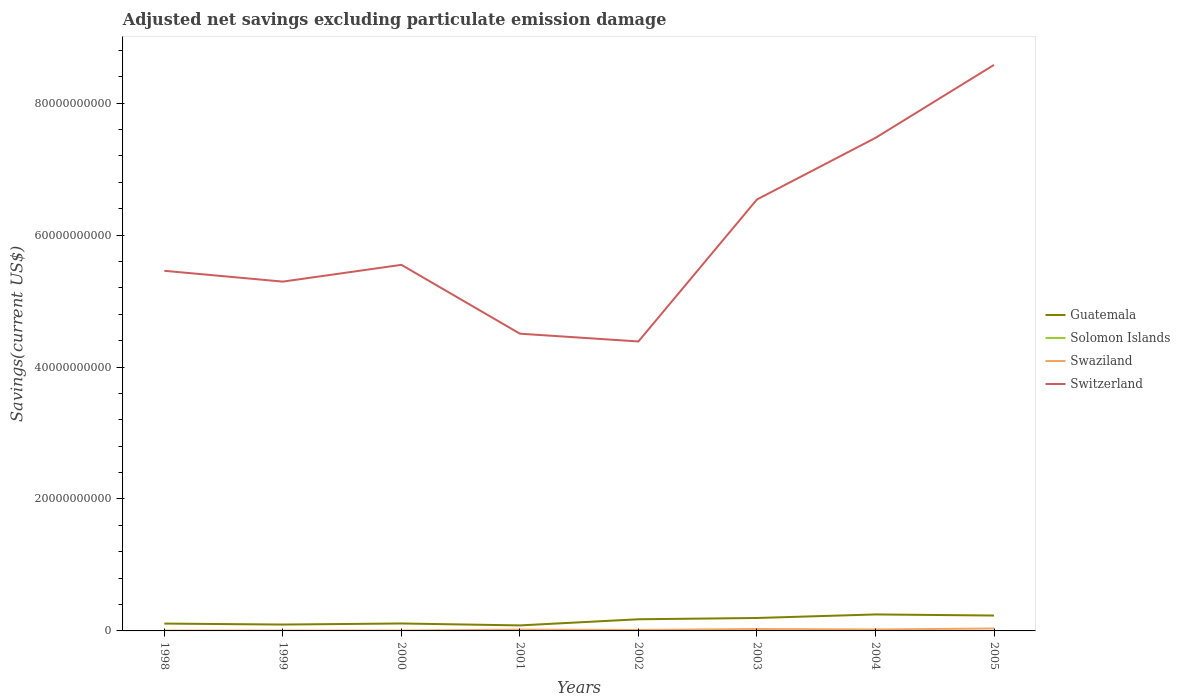How many different coloured lines are there?
Make the answer very short. 4. Across all years, what is the maximum adjusted net savings in Guatemala?
Your answer should be compact. 8.35e+08. What is the total adjusted net savings in Switzerland in the graph?
Your response must be concise. -4.07e+1. What is the difference between the highest and the second highest adjusted net savings in Guatemala?
Your answer should be compact. 1.66e+09. How many lines are there?
Ensure brevity in your answer.  4. How many years are there in the graph?
Your answer should be compact. 8. What is the difference between two consecutive major ticks on the Y-axis?
Provide a succinct answer. 2.00e+1. Are the values on the major ticks of Y-axis written in scientific E-notation?
Provide a short and direct response. No. Does the graph contain grids?
Your response must be concise. No. What is the title of the graph?
Ensure brevity in your answer.  Adjusted net savings excluding particulate emission damage. Does "Solomon Islands" appear as one of the legend labels in the graph?
Make the answer very short. Yes. What is the label or title of the X-axis?
Your answer should be very brief. Years. What is the label or title of the Y-axis?
Ensure brevity in your answer.  Savings(current US$). What is the Savings(current US$) in Guatemala in 1998?
Your answer should be very brief. 1.11e+09. What is the Savings(current US$) of Solomon Islands in 1998?
Ensure brevity in your answer.  0. What is the Savings(current US$) in Swaziland in 1998?
Your answer should be compact. 5.31e+07. What is the Savings(current US$) of Switzerland in 1998?
Make the answer very short. 5.46e+1. What is the Savings(current US$) in Guatemala in 1999?
Provide a short and direct response. 9.67e+08. What is the Savings(current US$) of Swaziland in 1999?
Make the answer very short. 5.98e+07. What is the Savings(current US$) of Switzerland in 1999?
Keep it short and to the point. 5.29e+1. What is the Savings(current US$) in Guatemala in 2000?
Offer a very short reply. 1.13e+09. What is the Savings(current US$) in Swaziland in 2000?
Provide a short and direct response. 5.99e+07. What is the Savings(current US$) of Switzerland in 2000?
Provide a succinct answer. 5.55e+1. What is the Savings(current US$) of Guatemala in 2001?
Give a very brief answer. 8.35e+08. What is the Savings(current US$) in Swaziland in 2001?
Give a very brief answer. 1.97e+08. What is the Savings(current US$) in Switzerland in 2001?
Offer a terse response. 4.51e+1. What is the Savings(current US$) of Guatemala in 2002?
Offer a very short reply. 1.77e+09. What is the Savings(current US$) of Swaziland in 2002?
Ensure brevity in your answer.  1.44e+08. What is the Savings(current US$) of Switzerland in 2002?
Ensure brevity in your answer.  4.39e+1. What is the Savings(current US$) of Guatemala in 2003?
Your response must be concise. 1.96e+09. What is the Savings(current US$) of Solomon Islands in 2003?
Offer a very short reply. 9.45e+05. What is the Savings(current US$) in Swaziland in 2003?
Provide a succinct answer. 2.91e+08. What is the Savings(current US$) in Switzerland in 2003?
Keep it short and to the point. 6.54e+1. What is the Savings(current US$) of Guatemala in 2004?
Your response must be concise. 2.50e+09. What is the Savings(current US$) of Solomon Islands in 2004?
Keep it short and to the point. 0. What is the Savings(current US$) of Swaziland in 2004?
Provide a short and direct response. 2.19e+08. What is the Savings(current US$) in Switzerland in 2004?
Make the answer very short. 7.47e+1. What is the Savings(current US$) in Guatemala in 2005?
Offer a very short reply. 2.33e+09. What is the Savings(current US$) of Swaziland in 2005?
Your answer should be very brief. 3.69e+08. What is the Savings(current US$) in Switzerland in 2005?
Provide a succinct answer. 8.58e+1. Across all years, what is the maximum Savings(current US$) in Guatemala?
Your response must be concise. 2.50e+09. Across all years, what is the maximum Savings(current US$) in Solomon Islands?
Ensure brevity in your answer.  9.45e+05. Across all years, what is the maximum Savings(current US$) in Swaziland?
Provide a short and direct response. 3.69e+08. Across all years, what is the maximum Savings(current US$) of Switzerland?
Your answer should be compact. 8.58e+1. Across all years, what is the minimum Savings(current US$) of Guatemala?
Your response must be concise. 8.35e+08. Across all years, what is the minimum Savings(current US$) of Solomon Islands?
Ensure brevity in your answer.  0. Across all years, what is the minimum Savings(current US$) in Swaziland?
Offer a very short reply. 5.31e+07. Across all years, what is the minimum Savings(current US$) in Switzerland?
Provide a short and direct response. 4.39e+1. What is the total Savings(current US$) in Guatemala in the graph?
Make the answer very short. 1.26e+1. What is the total Savings(current US$) in Solomon Islands in the graph?
Provide a short and direct response. 9.45e+05. What is the total Savings(current US$) in Swaziland in the graph?
Your answer should be very brief. 1.39e+09. What is the total Savings(current US$) in Switzerland in the graph?
Give a very brief answer. 4.78e+11. What is the difference between the Savings(current US$) in Guatemala in 1998 and that in 1999?
Offer a terse response. 1.46e+08. What is the difference between the Savings(current US$) of Swaziland in 1998 and that in 1999?
Ensure brevity in your answer.  -6.63e+06. What is the difference between the Savings(current US$) in Switzerland in 1998 and that in 1999?
Ensure brevity in your answer.  1.64e+09. What is the difference between the Savings(current US$) of Guatemala in 1998 and that in 2000?
Ensure brevity in your answer.  -1.32e+07. What is the difference between the Savings(current US$) of Swaziland in 1998 and that in 2000?
Keep it short and to the point. -6.71e+06. What is the difference between the Savings(current US$) in Switzerland in 1998 and that in 2000?
Your answer should be very brief. -9.01e+08. What is the difference between the Savings(current US$) in Guatemala in 1998 and that in 2001?
Offer a very short reply. 2.78e+08. What is the difference between the Savings(current US$) in Swaziland in 1998 and that in 2001?
Your answer should be compact. -1.44e+08. What is the difference between the Savings(current US$) in Switzerland in 1998 and that in 2001?
Give a very brief answer. 9.53e+09. What is the difference between the Savings(current US$) in Guatemala in 1998 and that in 2002?
Give a very brief answer. -6.53e+08. What is the difference between the Savings(current US$) in Swaziland in 1998 and that in 2002?
Ensure brevity in your answer.  -9.08e+07. What is the difference between the Savings(current US$) of Switzerland in 1998 and that in 2002?
Provide a succinct answer. 1.07e+1. What is the difference between the Savings(current US$) in Guatemala in 1998 and that in 2003?
Provide a succinct answer. -8.48e+08. What is the difference between the Savings(current US$) of Swaziland in 1998 and that in 2003?
Your answer should be compact. -2.38e+08. What is the difference between the Savings(current US$) of Switzerland in 1998 and that in 2003?
Offer a very short reply. -1.08e+1. What is the difference between the Savings(current US$) of Guatemala in 1998 and that in 2004?
Give a very brief answer. -1.38e+09. What is the difference between the Savings(current US$) of Swaziland in 1998 and that in 2004?
Your response must be concise. -1.66e+08. What is the difference between the Savings(current US$) of Switzerland in 1998 and that in 2004?
Make the answer very short. -2.01e+1. What is the difference between the Savings(current US$) in Guatemala in 1998 and that in 2005?
Give a very brief answer. -1.22e+09. What is the difference between the Savings(current US$) in Swaziland in 1998 and that in 2005?
Offer a very short reply. -3.16e+08. What is the difference between the Savings(current US$) of Switzerland in 1998 and that in 2005?
Your response must be concise. -3.12e+1. What is the difference between the Savings(current US$) in Guatemala in 1999 and that in 2000?
Give a very brief answer. -1.59e+08. What is the difference between the Savings(current US$) in Swaziland in 1999 and that in 2000?
Make the answer very short. -7.67e+04. What is the difference between the Savings(current US$) of Switzerland in 1999 and that in 2000?
Make the answer very short. -2.54e+09. What is the difference between the Savings(current US$) in Guatemala in 1999 and that in 2001?
Keep it short and to the point. 1.32e+08. What is the difference between the Savings(current US$) in Swaziland in 1999 and that in 2001?
Provide a succinct answer. -1.37e+08. What is the difference between the Savings(current US$) in Switzerland in 1999 and that in 2001?
Offer a very short reply. 7.89e+09. What is the difference between the Savings(current US$) in Guatemala in 1999 and that in 2002?
Offer a very short reply. -7.99e+08. What is the difference between the Savings(current US$) in Swaziland in 1999 and that in 2002?
Keep it short and to the point. -8.41e+07. What is the difference between the Savings(current US$) in Switzerland in 1999 and that in 2002?
Your response must be concise. 9.07e+09. What is the difference between the Savings(current US$) in Guatemala in 1999 and that in 2003?
Make the answer very short. -9.94e+08. What is the difference between the Savings(current US$) of Swaziland in 1999 and that in 2003?
Your answer should be very brief. -2.32e+08. What is the difference between the Savings(current US$) of Switzerland in 1999 and that in 2003?
Give a very brief answer. -1.25e+1. What is the difference between the Savings(current US$) in Guatemala in 1999 and that in 2004?
Your answer should be compact. -1.53e+09. What is the difference between the Savings(current US$) in Swaziland in 1999 and that in 2004?
Give a very brief answer. -1.60e+08. What is the difference between the Savings(current US$) of Switzerland in 1999 and that in 2004?
Keep it short and to the point. -2.18e+1. What is the difference between the Savings(current US$) in Guatemala in 1999 and that in 2005?
Keep it short and to the point. -1.37e+09. What is the difference between the Savings(current US$) of Swaziland in 1999 and that in 2005?
Provide a succinct answer. -3.09e+08. What is the difference between the Savings(current US$) in Switzerland in 1999 and that in 2005?
Keep it short and to the point. -3.28e+1. What is the difference between the Savings(current US$) in Guatemala in 2000 and that in 2001?
Your answer should be very brief. 2.91e+08. What is the difference between the Savings(current US$) in Swaziland in 2000 and that in 2001?
Offer a terse response. -1.37e+08. What is the difference between the Savings(current US$) in Switzerland in 2000 and that in 2001?
Make the answer very short. 1.04e+1. What is the difference between the Savings(current US$) of Guatemala in 2000 and that in 2002?
Offer a very short reply. -6.40e+08. What is the difference between the Savings(current US$) in Swaziland in 2000 and that in 2002?
Give a very brief answer. -8.41e+07. What is the difference between the Savings(current US$) of Switzerland in 2000 and that in 2002?
Offer a terse response. 1.16e+1. What is the difference between the Savings(current US$) in Guatemala in 2000 and that in 2003?
Offer a very short reply. -8.35e+08. What is the difference between the Savings(current US$) in Swaziland in 2000 and that in 2003?
Offer a terse response. -2.32e+08. What is the difference between the Savings(current US$) of Switzerland in 2000 and that in 2003?
Provide a short and direct response. -9.91e+09. What is the difference between the Savings(current US$) of Guatemala in 2000 and that in 2004?
Your answer should be very brief. -1.37e+09. What is the difference between the Savings(current US$) of Swaziland in 2000 and that in 2004?
Provide a succinct answer. -1.60e+08. What is the difference between the Savings(current US$) of Switzerland in 2000 and that in 2004?
Your answer should be very brief. -1.92e+1. What is the difference between the Savings(current US$) in Guatemala in 2000 and that in 2005?
Make the answer very short. -1.21e+09. What is the difference between the Savings(current US$) of Swaziland in 2000 and that in 2005?
Keep it short and to the point. -3.09e+08. What is the difference between the Savings(current US$) in Switzerland in 2000 and that in 2005?
Offer a terse response. -3.03e+1. What is the difference between the Savings(current US$) of Guatemala in 2001 and that in 2002?
Give a very brief answer. -9.30e+08. What is the difference between the Savings(current US$) in Swaziland in 2001 and that in 2002?
Ensure brevity in your answer.  5.32e+07. What is the difference between the Savings(current US$) in Switzerland in 2001 and that in 2002?
Your response must be concise. 1.18e+09. What is the difference between the Savings(current US$) of Guatemala in 2001 and that in 2003?
Ensure brevity in your answer.  -1.13e+09. What is the difference between the Savings(current US$) of Swaziland in 2001 and that in 2003?
Provide a short and direct response. -9.43e+07. What is the difference between the Savings(current US$) in Switzerland in 2001 and that in 2003?
Offer a terse response. -2.03e+1. What is the difference between the Savings(current US$) in Guatemala in 2001 and that in 2004?
Offer a very short reply. -1.66e+09. What is the difference between the Savings(current US$) of Swaziland in 2001 and that in 2004?
Your response must be concise. -2.23e+07. What is the difference between the Savings(current US$) of Switzerland in 2001 and that in 2004?
Offer a very short reply. -2.97e+1. What is the difference between the Savings(current US$) in Guatemala in 2001 and that in 2005?
Keep it short and to the point. -1.50e+09. What is the difference between the Savings(current US$) in Swaziland in 2001 and that in 2005?
Provide a succinct answer. -1.72e+08. What is the difference between the Savings(current US$) of Switzerland in 2001 and that in 2005?
Offer a very short reply. -4.07e+1. What is the difference between the Savings(current US$) of Guatemala in 2002 and that in 2003?
Ensure brevity in your answer.  -1.95e+08. What is the difference between the Savings(current US$) of Swaziland in 2002 and that in 2003?
Provide a succinct answer. -1.48e+08. What is the difference between the Savings(current US$) of Switzerland in 2002 and that in 2003?
Keep it short and to the point. -2.15e+1. What is the difference between the Savings(current US$) in Guatemala in 2002 and that in 2004?
Provide a succinct answer. -7.32e+08. What is the difference between the Savings(current US$) of Swaziland in 2002 and that in 2004?
Ensure brevity in your answer.  -7.55e+07. What is the difference between the Savings(current US$) of Switzerland in 2002 and that in 2004?
Provide a short and direct response. -3.09e+1. What is the difference between the Savings(current US$) of Guatemala in 2002 and that in 2005?
Offer a terse response. -5.67e+08. What is the difference between the Savings(current US$) in Swaziland in 2002 and that in 2005?
Provide a succinct answer. -2.25e+08. What is the difference between the Savings(current US$) in Switzerland in 2002 and that in 2005?
Give a very brief answer. -4.19e+1. What is the difference between the Savings(current US$) in Guatemala in 2003 and that in 2004?
Offer a very short reply. -5.36e+08. What is the difference between the Savings(current US$) in Swaziland in 2003 and that in 2004?
Your answer should be very brief. 7.20e+07. What is the difference between the Savings(current US$) in Switzerland in 2003 and that in 2004?
Offer a terse response. -9.33e+09. What is the difference between the Savings(current US$) of Guatemala in 2003 and that in 2005?
Your answer should be very brief. -3.71e+08. What is the difference between the Savings(current US$) in Swaziland in 2003 and that in 2005?
Keep it short and to the point. -7.72e+07. What is the difference between the Savings(current US$) in Switzerland in 2003 and that in 2005?
Your answer should be compact. -2.04e+1. What is the difference between the Savings(current US$) of Guatemala in 2004 and that in 2005?
Keep it short and to the point. 1.65e+08. What is the difference between the Savings(current US$) of Swaziland in 2004 and that in 2005?
Make the answer very short. -1.49e+08. What is the difference between the Savings(current US$) of Switzerland in 2004 and that in 2005?
Ensure brevity in your answer.  -1.11e+1. What is the difference between the Savings(current US$) in Guatemala in 1998 and the Savings(current US$) in Swaziland in 1999?
Ensure brevity in your answer.  1.05e+09. What is the difference between the Savings(current US$) in Guatemala in 1998 and the Savings(current US$) in Switzerland in 1999?
Make the answer very short. -5.18e+1. What is the difference between the Savings(current US$) in Swaziland in 1998 and the Savings(current US$) in Switzerland in 1999?
Give a very brief answer. -5.29e+1. What is the difference between the Savings(current US$) of Guatemala in 1998 and the Savings(current US$) of Swaziland in 2000?
Your response must be concise. 1.05e+09. What is the difference between the Savings(current US$) in Guatemala in 1998 and the Savings(current US$) in Switzerland in 2000?
Keep it short and to the point. -5.44e+1. What is the difference between the Savings(current US$) of Swaziland in 1998 and the Savings(current US$) of Switzerland in 2000?
Your answer should be very brief. -5.54e+1. What is the difference between the Savings(current US$) of Guatemala in 1998 and the Savings(current US$) of Swaziland in 2001?
Make the answer very short. 9.16e+08. What is the difference between the Savings(current US$) of Guatemala in 1998 and the Savings(current US$) of Switzerland in 2001?
Your answer should be compact. -4.39e+1. What is the difference between the Savings(current US$) in Swaziland in 1998 and the Savings(current US$) in Switzerland in 2001?
Provide a short and direct response. -4.50e+1. What is the difference between the Savings(current US$) in Guatemala in 1998 and the Savings(current US$) in Swaziland in 2002?
Keep it short and to the point. 9.69e+08. What is the difference between the Savings(current US$) of Guatemala in 1998 and the Savings(current US$) of Switzerland in 2002?
Your answer should be very brief. -4.28e+1. What is the difference between the Savings(current US$) of Swaziland in 1998 and the Savings(current US$) of Switzerland in 2002?
Your response must be concise. -4.38e+1. What is the difference between the Savings(current US$) of Guatemala in 1998 and the Savings(current US$) of Solomon Islands in 2003?
Offer a very short reply. 1.11e+09. What is the difference between the Savings(current US$) of Guatemala in 1998 and the Savings(current US$) of Swaziland in 2003?
Give a very brief answer. 8.22e+08. What is the difference between the Savings(current US$) of Guatemala in 1998 and the Savings(current US$) of Switzerland in 2003?
Provide a succinct answer. -6.43e+1. What is the difference between the Savings(current US$) of Swaziland in 1998 and the Savings(current US$) of Switzerland in 2003?
Make the answer very short. -6.53e+1. What is the difference between the Savings(current US$) in Guatemala in 1998 and the Savings(current US$) in Swaziland in 2004?
Keep it short and to the point. 8.94e+08. What is the difference between the Savings(current US$) of Guatemala in 1998 and the Savings(current US$) of Switzerland in 2004?
Ensure brevity in your answer.  -7.36e+1. What is the difference between the Savings(current US$) in Swaziland in 1998 and the Savings(current US$) in Switzerland in 2004?
Provide a succinct answer. -7.47e+1. What is the difference between the Savings(current US$) in Guatemala in 1998 and the Savings(current US$) in Swaziland in 2005?
Give a very brief answer. 7.44e+08. What is the difference between the Savings(current US$) in Guatemala in 1998 and the Savings(current US$) in Switzerland in 2005?
Provide a short and direct response. -8.47e+1. What is the difference between the Savings(current US$) of Swaziland in 1998 and the Savings(current US$) of Switzerland in 2005?
Keep it short and to the point. -8.57e+1. What is the difference between the Savings(current US$) of Guatemala in 1999 and the Savings(current US$) of Swaziland in 2000?
Your response must be concise. 9.07e+08. What is the difference between the Savings(current US$) of Guatemala in 1999 and the Savings(current US$) of Switzerland in 2000?
Provide a short and direct response. -5.45e+1. What is the difference between the Savings(current US$) of Swaziland in 1999 and the Savings(current US$) of Switzerland in 2000?
Provide a short and direct response. -5.54e+1. What is the difference between the Savings(current US$) of Guatemala in 1999 and the Savings(current US$) of Swaziland in 2001?
Provide a succinct answer. 7.70e+08. What is the difference between the Savings(current US$) of Guatemala in 1999 and the Savings(current US$) of Switzerland in 2001?
Keep it short and to the point. -4.41e+1. What is the difference between the Savings(current US$) in Swaziland in 1999 and the Savings(current US$) in Switzerland in 2001?
Your answer should be compact. -4.50e+1. What is the difference between the Savings(current US$) of Guatemala in 1999 and the Savings(current US$) of Swaziland in 2002?
Make the answer very short. 8.23e+08. What is the difference between the Savings(current US$) in Guatemala in 1999 and the Savings(current US$) in Switzerland in 2002?
Offer a terse response. -4.29e+1. What is the difference between the Savings(current US$) of Swaziland in 1999 and the Savings(current US$) of Switzerland in 2002?
Your answer should be compact. -4.38e+1. What is the difference between the Savings(current US$) in Guatemala in 1999 and the Savings(current US$) in Solomon Islands in 2003?
Keep it short and to the point. 9.66e+08. What is the difference between the Savings(current US$) in Guatemala in 1999 and the Savings(current US$) in Swaziland in 2003?
Provide a succinct answer. 6.76e+08. What is the difference between the Savings(current US$) of Guatemala in 1999 and the Savings(current US$) of Switzerland in 2003?
Your response must be concise. -6.44e+1. What is the difference between the Savings(current US$) in Swaziland in 1999 and the Savings(current US$) in Switzerland in 2003?
Your answer should be compact. -6.53e+1. What is the difference between the Savings(current US$) of Guatemala in 1999 and the Savings(current US$) of Swaziland in 2004?
Keep it short and to the point. 7.48e+08. What is the difference between the Savings(current US$) of Guatemala in 1999 and the Savings(current US$) of Switzerland in 2004?
Your answer should be compact. -7.38e+1. What is the difference between the Savings(current US$) in Swaziland in 1999 and the Savings(current US$) in Switzerland in 2004?
Your answer should be compact. -7.47e+1. What is the difference between the Savings(current US$) in Guatemala in 1999 and the Savings(current US$) in Swaziland in 2005?
Keep it short and to the point. 5.99e+08. What is the difference between the Savings(current US$) of Guatemala in 1999 and the Savings(current US$) of Switzerland in 2005?
Offer a very short reply. -8.48e+1. What is the difference between the Savings(current US$) of Swaziland in 1999 and the Savings(current US$) of Switzerland in 2005?
Offer a terse response. -8.57e+1. What is the difference between the Savings(current US$) of Guatemala in 2000 and the Savings(current US$) of Swaziland in 2001?
Make the answer very short. 9.29e+08. What is the difference between the Savings(current US$) of Guatemala in 2000 and the Savings(current US$) of Switzerland in 2001?
Keep it short and to the point. -4.39e+1. What is the difference between the Savings(current US$) in Swaziland in 2000 and the Savings(current US$) in Switzerland in 2001?
Make the answer very short. -4.50e+1. What is the difference between the Savings(current US$) of Guatemala in 2000 and the Savings(current US$) of Swaziland in 2002?
Make the answer very short. 9.82e+08. What is the difference between the Savings(current US$) in Guatemala in 2000 and the Savings(current US$) in Switzerland in 2002?
Provide a succinct answer. -4.27e+1. What is the difference between the Savings(current US$) in Swaziland in 2000 and the Savings(current US$) in Switzerland in 2002?
Make the answer very short. -4.38e+1. What is the difference between the Savings(current US$) of Guatemala in 2000 and the Savings(current US$) of Solomon Islands in 2003?
Make the answer very short. 1.13e+09. What is the difference between the Savings(current US$) in Guatemala in 2000 and the Savings(current US$) in Swaziland in 2003?
Your response must be concise. 8.35e+08. What is the difference between the Savings(current US$) of Guatemala in 2000 and the Savings(current US$) of Switzerland in 2003?
Provide a succinct answer. -6.43e+1. What is the difference between the Savings(current US$) of Swaziland in 2000 and the Savings(current US$) of Switzerland in 2003?
Offer a very short reply. -6.53e+1. What is the difference between the Savings(current US$) of Guatemala in 2000 and the Savings(current US$) of Swaziland in 2004?
Offer a terse response. 9.07e+08. What is the difference between the Savings(current US$) in Guatemala in 2000 and the Savings(current US$) in Switzerland in 2004?
Offer a very short reply. -7.36e+1. What is the difference between the Savings(current US$) of Swaziland in 2000 and the Savings(current US$) of Switzerland in 2004?
Ensure brevity in your answer.  -7.47e+1. What is the difference between the Savings(current US$) in Guatemala in 2000 and the Savings(current US$) in Swaziland in 2005?
Ensure brevity in your answer.  7.58e+08. What is the difference between the Savings(current US$) in Guatemala in 2000 and the Savings(current US$) in Switzerland in 2005?
Provide a short and direct response. -8.47e+1. What is the difference between the Savings(current US$) in Swaziland in 2000 and the Savings(current US$) in Switzerland in 2005?
Provide a short and direct response. -8.57e+1. What is the difference between the Savings(current US$) of Guatemala in 2001 and the Savings(current US$) of Swaziland in 2002?
Make the answer very short. 6.91e+08. What is the difference between the Savings(current US$) of Guatemala in 2001 and the Savings(current US$) of Switzerland in 2002?
Make the answer very short. -4.30e+1. What is the difference between the Savings(current US$) in Swaziland in 2001 and the Savings(current US$) in Switzerland in 2002?
Offer a terse response. -4.37e+1. What is the difference between the Savings(current US$) of Guatemala in 2001 and the Savings(current US$) of Solomon Islands in 2003?
Keep it short and to the point. 8.34e+08. What is the difference between the Savings(current US$) in Guatemala in 2001 and the Savings(current US$) in Swaziland in 2003?
Ensure brevity in your answer.  5.44e+08. What is the difference between the Savings(current US$) of Guatemala in 2001 and the Savings(current US$) of Switzerland in 2003?
Offer a terse response. -6.46e+1. What is the difference between the Savings(current US$) in Swaziland in 2001 and the Savings(current US$) in Switzerland in 2003?
Offer a terse response. -6.52e+1. What is the difference between the Savings(current US$) in Guatemala in 2001 and the Savings(current US$) in Swaziland in 2004?
Offer a very short reply. 6.16e+08. What is the difference between the Savings(current US$) in Guatemala in 2001 and the Savings(current US$) in Switzerland in 2004?
Make the answer very short. -7.39e+1. What is the difference between the Savings(current US$) in Swaziland in 2001 and the Savings(current US$) in Switzerland in 2004?
Ensure brevity in your answer.  -7.45e+1. What is the difference between the Savings(current US$) of Guatemala in 2001 and the Savings(current US$) of Swaziland in 2005?
Keep it short and to the point. 4.67e+08. What is the difference between the Savings(current US$) in Guatemala in 2001 and the Savings(current US$) in Switzerland in 2005?
Your answer should be compact. -8.50e+1. What is the difference between the Savings(current US$) of Swaziland in 2001 and the Savings(current US$) of Switzerland in 2005?
Your answer should be very brief. -8.56e+1. What is the difference between the Savings(current US$) of Guatemala in 2002 and the Savings(current US$) of Solomon Islands in 2003?
Your answer should be very brief. 1.76e+09. What is the difference between the Savings(current US$) in Guatemala in 2002 and the Savings(current US$) in Swaziland in 2003?
Your answer should be very brief. 1.47e+09. What is the difference between the Savings(current US$) in Guatemala in 2002 and the Savings(current US$) in Switzerland in 2003?
Ensure brevity in your answer.  -6.36e+1. What is the difference between the Savings(current US$) of Swaziland in 2002 and the Savings(current US$) of Switzerland in 2003?
Give a very brief answer. -6.53e+1. What is the difference between the Savings(current US$) in Guatemala in 2002 and the Savings(current US$) in Swaziland in 2004?
Provide a succinct answer. 1.55e+09. What is the difference between the Savings(current US$) in Guatemala in 2002 and the Savings(current US$) in Switzerland in 2004?
Ensure brevity in your answer.  -7.30e+1. What is the difference between the Savings(current US$) of Swaziland in 2002 and the Savings(current US$) of Switzerland in 2004?
Give a very brief answer. -7.46e+1. What is the difference between the Savings(current US$) in Guatemala in 2002 and the Savings(current US$) in Swaziland in 2005?
Your answer should be compact. 1.40e+09. What is the difference between the Savings(current US$) in Guatemala in 2002 and the Savings(current US$) in Switzerland in 2005?
Offer a very short reply. -8.40e+1. What is the difference between the Savings(current US$) in Swaziland in 2002 and the Savings(current US$) in Switzerland in 2005?
Offer a terse response. -8.57e+1. What is the difference between the Savings(current US$) in Guatemala in 2003 and the Savings(current US$) in Swaziland in 2004?
Offer a very short reply. 1.74e+09. What is the difference between the Savings(current US$) in Guatemala in 2003 and the Savings(current US$) in Switzerland in 2004?
Make the answer very short. -7.28e+1. What is the difference between the Savings(current US$) in Solomon Islands in 2003 and the Savings(current US$) in Swaziland in 2004?
Provide a short and direct response. -2.18e+08. What is the difference between the Savings(current US$) in Solomon Islands in 2003 and the Savings(current US$) in Switzerland in 2004?
Offer a terse response. -7.47e+1. What is the difference between the Savings(current US$) of Swaziland in 2003 and the Savings(current US$) of Switzerland in 2004?
Keep it short and to the point. -7.44e+1. What is the difference between the Savings(current US$) in Guatemala in 2003 and the Savings(current US$) in Swaziland in 2005?
Make the answer very short. 1.59e+09. What is the difference between the Savings(current US$) in Guatemala in 2003 and the Savings(current US$) in Switzerland in 2005?
Your answer should be very brief. -8.38e+1. What is the difference between the Savings(current US$) in Solomon Islands in 2003 and the Savings(current US$) in Swaziland in 2005?
Give a very brief answer. -3.68e+08. What is the difference between the Savings(current US$) in Solomon Islands in 2003 and the Savings(current US$) in Switzerland in 2005?
Your answer should be very brief. -8.58e+1. What is the difference between the Savings(current US$) of Swaziland in 2003 and the Savings(current US$) of Switzerland in 2005?
Offer a very short reply. -8.55e+1. What is the difference between the Savings(current US$) of Guatemala in 2004 and the Savings(current US$) of Swaziland in 2005?
Your answer should be compact. 2.13e+09. What is the difference between the Savings(current US$) in Guatemala in 2004 and the Savings(current US$) in Switzerland in 2005?
Provide a succinct answer. -8.33e+1. What is the difference between the Savings(current US$) of Swaziland in 2004 and the Savings(current US$) of Switzerland in 2005?
Your answer should be compact. -8.56e+1. What is the average Savings(current US$) of Guatemala per year?
Keep it short and to the point. 1.57e+09. What is the average Savings(current US$) of Solomon Islands per year?
Make the answer very short. 1.18e+05. What is the average Savings(current US$) of Swaziland per year?
Offer a very short reply. 1.74e+08. What is the average Savings(current US$) in Switzerland per year?
Your response must be concise. 5.97e+1. In the year 1998, what is the difference between the Savings(current US$) in Guatemala and Savings(current US$) in Swaziland?
Provide a succinct answer. 1.06e+09. In the year 1998, what is the difference between the Savings(current US$) in Guatemala and Savings(current US$) in Switzerland?
Make the answer very short. -5.35e+1. In the year 1998, what is the difference between the Savings(current US$) in Swaziland and Savings(current US$) in Switzerland?
Keep it short and to the point. -5.45e+1. In the year 1999, what is the difference between the Savings(current US$) of Guatemala and Savings(current US$) of Swaziland?
Your response must be concise. 9.07e+08. In the year 1999, what is the difference between the Savings(current US$) in Guatemala and Savings(current US$) in Switzerland?
Your answer should be very brief. -5.20e+1. In the year 1999, what is the difference between the Savings(current US$) in Swaziland and Savings(current US$) in Switzerland?
Keep it short and to the point. -5.29e+1. In the year 2000, what is the difference between the Savings(current US$) of Guatemala and Savings(current US$) of Swaziland?
Offer a terse response. 1.07e+09. In the year 2000, what is the difference between the Savings(current US$) of Guatemala and Savings(current US$) of Switzerland?
Your answer should be very brief. -5.44e+1. In the year 2000, what is the difference between the Savings(current US$) of Swaziland and Savings(current US$) of Switzerland?
Ensure brevity in your answer.  -5.54e+1. In the year 2001, what is the difference between the Savings(current US$) in Guatemala and Savings(current US$) in Swaziland?
Provide a succinct answer. 6.38e+08. In the year 2001, what is the difference between the Savings(current US$) of Guatemala and Savings(current US$) of Switzerland?
Provide a succinct answer. -4.42e+1. In the year 2001, what is the difference between the Savings(current US$) in Swaziland and Savings(current US$) in Switzerland?
Your answer should be compact. -4.49e+1. In the year 2002, what is the difference between the Savings(current US$) in Guatemala and Savings(current US$) in Swaziland?
Your answer should be very brief. 1.62e+09. In the year 2002, what is the difference between the Savings(current US$) of Guatemala and Savings(current US$) of Switzerland?
Your answer should be compact. -4.21e+1. In the year 2002, what is the difference between the Savings(current US$) of Swaziland and Savings(current US$) of Switzerland?
Ensure brevity in your answer.  -4.37e+1. In the year 2003, what is the difference between the Savings(current US$) of Guatemala and Savings(current US$) of Solomon Islands?
Provide a succinct answer. 1.96e+09. In the year 2003, what is the difference between the Savings(current US$) of Guatemala and Savings(current US$) of Swaziland?
Your answer should be compact. 1.67e+09. In the year 2003, what is the difference between the Savings(current US$) in Guatemala and Savings(current US$) in Switzerland?
Provide a short and direct response. -6.34e+1. In the year 2003, what is the difference between the Savings(current US$) of Solomon Islands and Savings(current US$) of Swaziland?
Give a very brief answer. -2.90e+08. In the year 2003, what is the difference between the Savings(current US$) in Solomon Islands and Savings(current US$) in Switzerland?
Make the answer very short. -6.54e+1. In the year 2003, what is the difference between the Savings(current US$) in Swaziland and Savings(current US$) in Switzerland?
Provide a short and direct response. -6.51e+1. In the year 2004, what is the difference between the Savings(current US$) in Guatemala and Savings(current US$) in Swaziland?
Your response must be concise. 2.28e+09. In the year 2004, what is the difference between the Savings(current US$) in Guatemala and Savings(current US$) in Switzerland?
Your answer should be very brief. -7.22e+1. In the year 2004, what is the difference between the Savings(current US$) of Swaziland and Savings(current US$) of Switzerland?
Your answer should be very brief. -7.45e+1. In the year 2005, what is the difference between the Savings(current US$) in Guatemala and Savings(current US$) in Swaziland?
Provide a short and direct response. 1.96e+09. In the year 2005, what is the difference between the Savings(current US$) of Guatemala and Savings(current US$) of Switzerland?
Give a very brief answer. -8.35e+1. In the year 2005, what is the difference between the Savings(current US$) of Swaziland and Savings(current US$) of Switzerland?
Offer a terse response. -8.54e+1. What is the ratio of the Savings(current US$) of Guatemala in 1998 to that in 1999?
Your response must be concise. 1.15. What is the ratio of the Savings(current US$) in Swaziland in 1998 to that in 1999?
Your answer should be compact. 0.89. What is the ratio of the Savings(current US$) of Switzerland in 1998 to that in 1999?
Make the answer very short. 1.03. What is the ratio of the Savings(current US$) in Guatemala in 1998 to that in 2000?
Offer a very short reply. 0.99. What is the ratio of the Savings(current US$) in Swaziland in 1998 to that in 2000?
Provide a short and direct response. 0.89. What is the ratio of the Savings(current US$) in Switzerland in 1998 to that in 2000?
Your answer should be compact. 0.98. What is the ratio of the Savings(current US$) in Guatemala in 1998 to that in 2001?
Your answer should be compact. 1.33. What is the ratio of the Savings(current US$) in Swaziland in 1998 to that in 2001?
Offer a very short reply. 0.27. What is the ratio of the Savings(current US$) in Switzerland in 1998 to that in 2001?
Ensure brevity in your answer.  1.21. What is the ratio of the Savings(current US$) in Guatemala in 1998 to that in 2002?
Ensure brevity in your answer.  0.63. What is the ratio of the Savings(current US$) in Swaziland in 1998 to that in 2002?
Your answer should be compact. 0.37. What is the ratio of the Savings(current US$) of Switzerland in 1998 to that in 2002?
Keep it short and to the point. 1.24. What is the ratio of the Savings(current US$) of Guatemala in 1998 to that in 2003?
Your response must be concise. 0.57. What is the ratio of the Savings(current US$) of Swaziland in 1998 to that in 2003?
Give a very brief answer. 0.18. What is the ratio of the Savings(current US$) of Switzerland in 1998 to that in 2003?
Keep it short and to the point. 0.83. What is the ratio of the Savings(current US$) in Guatemala in 1998 to that in 2004?
Keep it short and to the point. 0.45. What is the ratio of the Savings(current US$) in Swaziland in 1998 to that in 2004?
Offer a terse response. 0.24. What is the ratio of the Savings(current US$) in Switzerland in 1998 to that in 2004?
Your response must be concise. 0.73. What is the ratio of the Savings(current US$) of Guatemala in 1998 to that in 2005?
Offer a terse response. 0.48. What is the ratio of the Savings(current US$) in Swaziland in 1998 to that in 2005?
Your answer should be compact. 0.14. What is the ratio of the Savings(current US$) of Switzerland in 1998 to that in 2005?
Keep it short and to the point. 0.64. What is the ratio of the Savings(current US$) in Guatemala in 1999 to that in 2000?
Keep it short and to the point. 0.86. What is the ratio of the Savings(current US$) of Switzerland in 1999 to that in 2000?
Give a very brief answer. 0.95. What is the ratio of the Savings(current US$) in Guatemala in 1999 to that in 2001?
Your answer should be compact. 1.16. What is the ratio of the Savings(current US$) in Swaziland in 1999 to that in 2001?
Offer a terse response. 0.3. What is the ratio of the Savings(current US$) of Switzerland in 1999 to that in 2001?
Provide a succinct answer. 1.18. What is the ratio of the Savings(current US$) of Guatemala in 1999 to that in 2002?
Provide a short and direct response. 0.55. What is the ratio of the Savings(current US$) of Swaziland in 1999 to that in 2002?
Your response must be concise. 0.42. What is the ratio of the Savings(current US$) in Switzerland in 1999 to that in 2002?
Offer a very short reply. 1.21. What is the ratio of the Savings(current US$) of Guatemala in 1999 to that in 2003?
Your response must be concise. 0.49. What is the ratio of the Savings(current US$) in Swaziland in 1999 to that in 2003?
Provide a short and direct response. 0.21. What is the ratio of the Savings(current US$) of Switzerland in 1999 to that in 2003?
Your answer should be very brief. 0.81. What is the ratio of the Savings(current US$) in Guatemala in 1999 to that in 2004?
Your answer should be very brief. 0.39. What is the ratio of the Savings(current US$) of Swaziland in 1999 to that in 2004?
Your answer should be compact. 0.27. What is the ratio of the Savings(current US$) in Switzerland in 1999 to that in 2004?
Your answer should be compact. 0.71. What is the ratio of the Savings(current US$) in Guatemala in 1999 to that in 2005?
Offer a terse response. 0.41. What is the ratio of the Savings(current US$) in Swaziland in 1999 to that in 2005?
Offer a very short reply. 0.16. What is the ratio of the Savings(current US$) of Switzerland in 1999 to that in 2005?
Ensure brevity in your answer.  0.62. What is the ratio of the Savings(current US$) of Guatemala in 2000 to that in 2001?
Provide a short and direct response. 1.35. What is the ratio of the Savings(current US$) in Swaziland in 2000 to that in 2001?
Ensure brevity in your answer.  0.3. What is the ratio of the Savings(current US$) of Switzerland in 2000 to that in 2001?
Make the answer very short. 1.23. What is the ratio of the Savings(current US$) in Guatemala in 2000 to that in 2002?
Your answer should be very brief. 0.64. What is the ratio of the Savings(current US$) of Swaziland in 2000 to that in 2002?
Offer a very short reply. 0.42. What is the ratio of the Savings(current US$) of Switzerland in 2000 to that in 2002?
Keep it short and to the point. 1.26. What is the ratio of the Savings(current US$) of Guatemala in 2000 to that in 2003?
Your answer should be very brief. 0.57. What is the ratio of the Savings(current US$) in Swaziland in 2000 to that in 2003?
Provide a succinct answer. 0.21. What is the ratio of the Savings(current US$) in Switzerland in 2000 to that in 2003?
Ensure brevity in your answer.  0.85. What is the ratio of the Savings(current US$) of Guatemala in 2000 to that in 2004?
Provide a succinct answer. 0.45. What is the ratio of the Savings(current US$) in Swaziland in 2000 to that in 2004?
Keep it short and to the point. 0.27. What is the ratio of the Savings(current US$) in Switzerland in 2000 to that in 2004?
Provide a succinct answer. 0.74. What is the ratio of the Savings(current US$) of Guatemala in 2000 to that in 2005?
Your response must be concise. 0.48. What is the ratio of the Savings(current US$) in Swaziland in 2000 to that in 2005?
Ensure brevity in your answer.  0.16. What is the ratio of the Savings(current US$) of Switzerland in 2000 to that in 2005?
Provide a succinct answer. 0.65. What is the ratio of the Savings(current US$) of Guatemala in 2001 to that in 2002?
Your response must be concise. 0.47. What is the ratio of the Savings(current US$) of Swaziland in 2001 to that in 2002?
Ensure brevity in your answer.  1.37. What is the ratio of the Savings(current US$) of Switzerland in 2001 to that in 2002?
Your answer should be very brief. 1.03. What is the ratio of the Savings(current US$) of Guatemala in 2001 to that in 2003?
Provide a succinct answer. 0.43. What is the ratio of the Savings(current US$) of Swaziland in 2001 to that in 2003?
Offer a very short reply. 0.68. What is the ratio of the Savings(current US$) of Switzerland in 2001 to that in 2003?
Offer a terse response. 0.69. What is the ratio of the Savings(current US$) of Guatemala in 2001 to that in 2004?
Your answer should be very brief. 0.33. What is the ratio of the Savings(current US$) in Swaziland in 2001 to that in 2004?
Make the answer very short. 0.9. What is the ratio of the Savings(current US$) of Switzerland in 2001 to that in 2004?
Your answer should be compact. 0.6. What is the ratio of the Savings(current US$) of Guatemala in 2001 to that in 2005?
Offer a terse response. 0.36. What is the ratio of the Savings(current US$) of Swaziland in 2001 to that in 2005?
Offer a terse response. 0.53. What is the ratio of the Savings(current US$) in Switzerland in 2001 to that in 2005?
Your answer should be very brief. 0.53. What is the ratio of the Savings(current US$) of Guatemala in 2002 to that in 2003?
Offer a very short reply. 0.9. What is the ratio of the Savings(current US$) in Swaziland in 2002 to that in 2003?
Provide a succinct answer. 0.49. What is the ratio of the Savings(current US$) of Switzerland in 2002 to that in 2003?
Your response must be concise. 0.67. What is the ratio of the Savings(current US$) of Guatemala in 2002 to that in 2004?
Make the answer very short. 0.71. What is the ratio of the Savings(current US$) in Swaziland in 2002 to that in 2004?
Make the answer very short. 0.66. What is the ratio of the Savings(current US$) in Switzerland in 2002 to that in 2004?
Provide a succinct answer. 0.59. What is the ratio of the Savings(current US$) in Guatemala in 2002 to that in 2005?
Offer a very short reply. 0.76. What is the ratio of the Savings(current US$) of Swaziland in 2002 to that in 2005?
Your response must be concise. 0.39. What is the ratio of the Savings(current US$) of Switzerland in 2002 to that in 2005?
Offer a terse response. 0.51. What is the ratio of the Savings(current US$) of Guatemala in 2003 to that in 2004?
Offer a terse response. 0.79. What is the ratio of the Savings(current US$) in Swaziland in 2003 to that in 2004?
Provide a short and direct response. 1.33. What is the ratio of the Savings(current US$) of Switzerland in 2003 to that in 2004?
Provide a succinct answer. 0.88. What is the ratio of the Savings(current US$) of Guatemala in 2003 to that in 2005?
Provide a succinct answer. 0.84. What is the ratio of the Savings(current US$) in Swaziland in 2003 to that in 2005?
Provide a short and direct response. 0.79. What is the ratio of the Savings(current US$) in Switzerland in 2003 to that in 2005?
Provide a succinct answer. 0.76. What is the ratio of the Savings(current US$) of Guatemala in 2004 to that in 2005?
Ensure brevity in your answer.  1.07. What is the ratio of the Savings(current US$) of Swaziland in 2004 to that in 2005?
Provide a succinct answer. 0.6. What is the ratio of the Savings(current US$) in Switzerland in 2004 to that in 2005?
Keep it short and to the point. 0.87. What is the difference between the highest and the second highest Savings(current US$) in Guatemala?
Offer a very short reply. 1.65e+08. What is the difference between the highest and the second highest Savings(current US$) in Swaziland?
Offer a terse response. 7.72e+07. What is the difference between the highest and the second highest Savings(current US$) of Switzerland?
Ensure brevity in your answer.  1.11e+1. What is the difference between the highest and the lowest Savings(current US$) of Guatemala?
Offer a terse response. 1.66e+09. What is the difference between the highest and the lowest Savings(current US$) in Solomon Islands?
Give a very brief answer. 9.45e+05. What is the difference between the highest and the lowest Savings(current US$) in Swaziland?
Keep it short and to the point. 3.16e+08. What is the difference between the highest and the lowest Savings(current US$) of Switzerland?
Provide a succinct answer. 4.19e+1. 